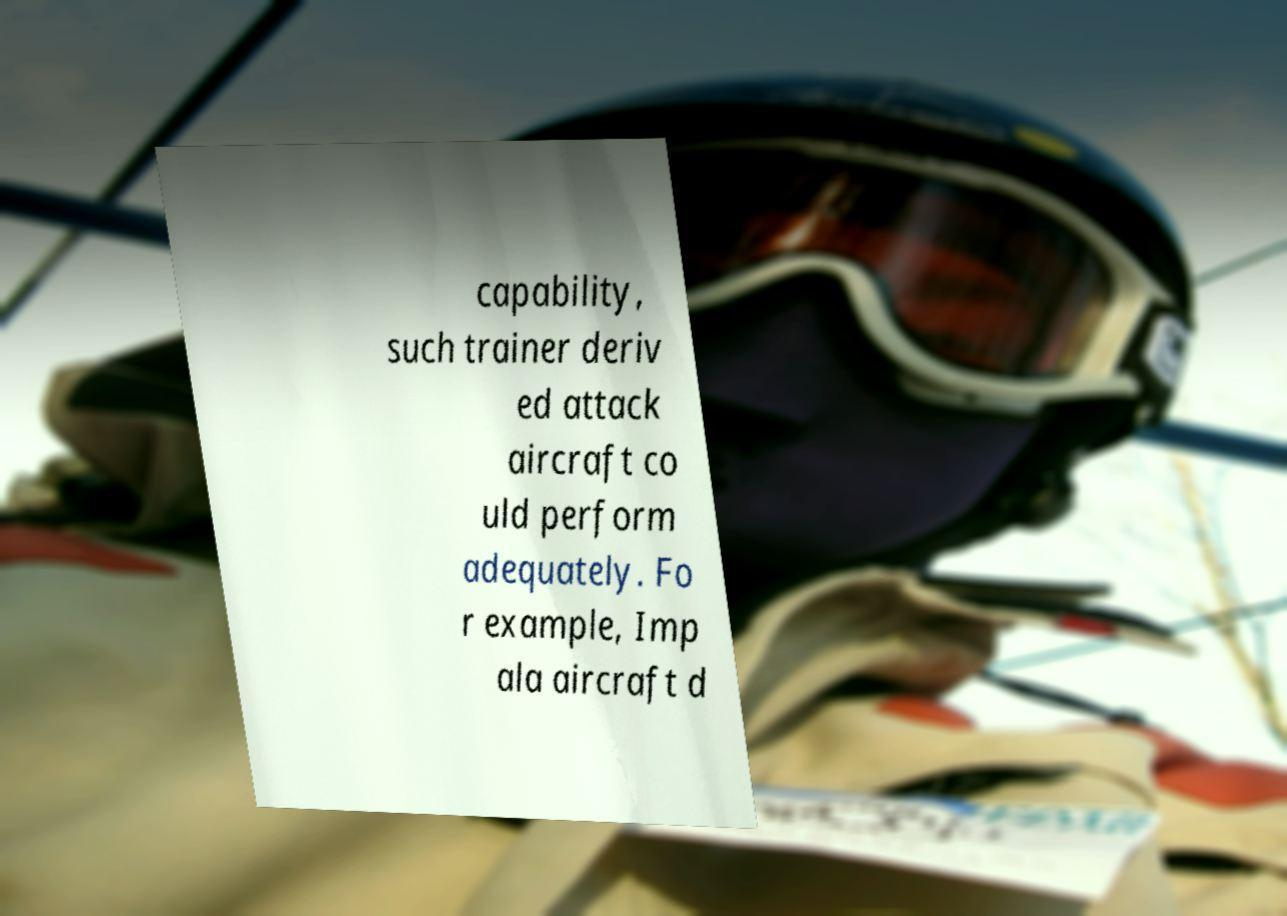Could you extract and type out the text from this image? capability, such trainer deriv ed attack aircraft co uld perform adequately. Fo r example, Imp ala aircraft d 